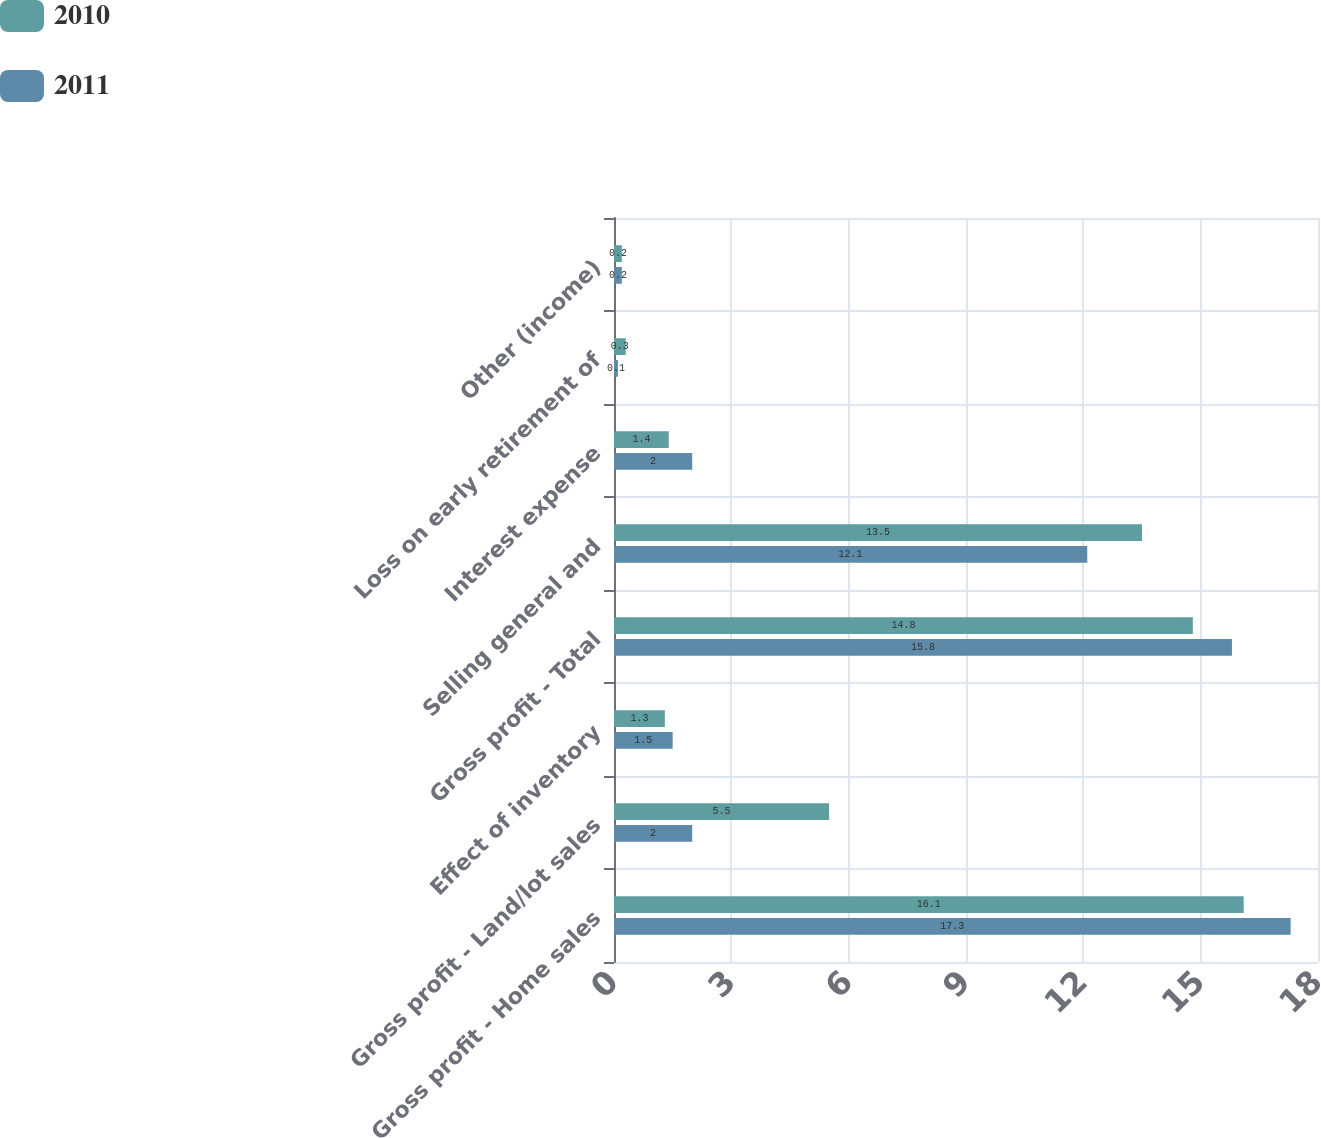Convert chart to OTSL. <chart><loc_0><loc_0><loc_500><loc_500><stacked_bar_chart><ecel><fcel>Gross profit - Home sales<fcel>Gross profit - Land/lot sales<fcel>Effect of inventory<fcel>Gross profit - Total<fcel>Selling general and<fcel>Interest expense<fcel>Loss on early retirement of<fcel>Other (income)<nl><fcel>2010<fcel>16.1<fcel>5.5<fcel>1.3<fcel>14.8<fcel>13.5<fcel>1.4<fcel>0.3<fcel>0.2<nl><fcel>2011<fcel>17.3<fcel>2<fcel>1.5<fcel>15.8<fcel>12.1<fcel>2<fcel>0.1<fcel>0.2<nl></chart> 